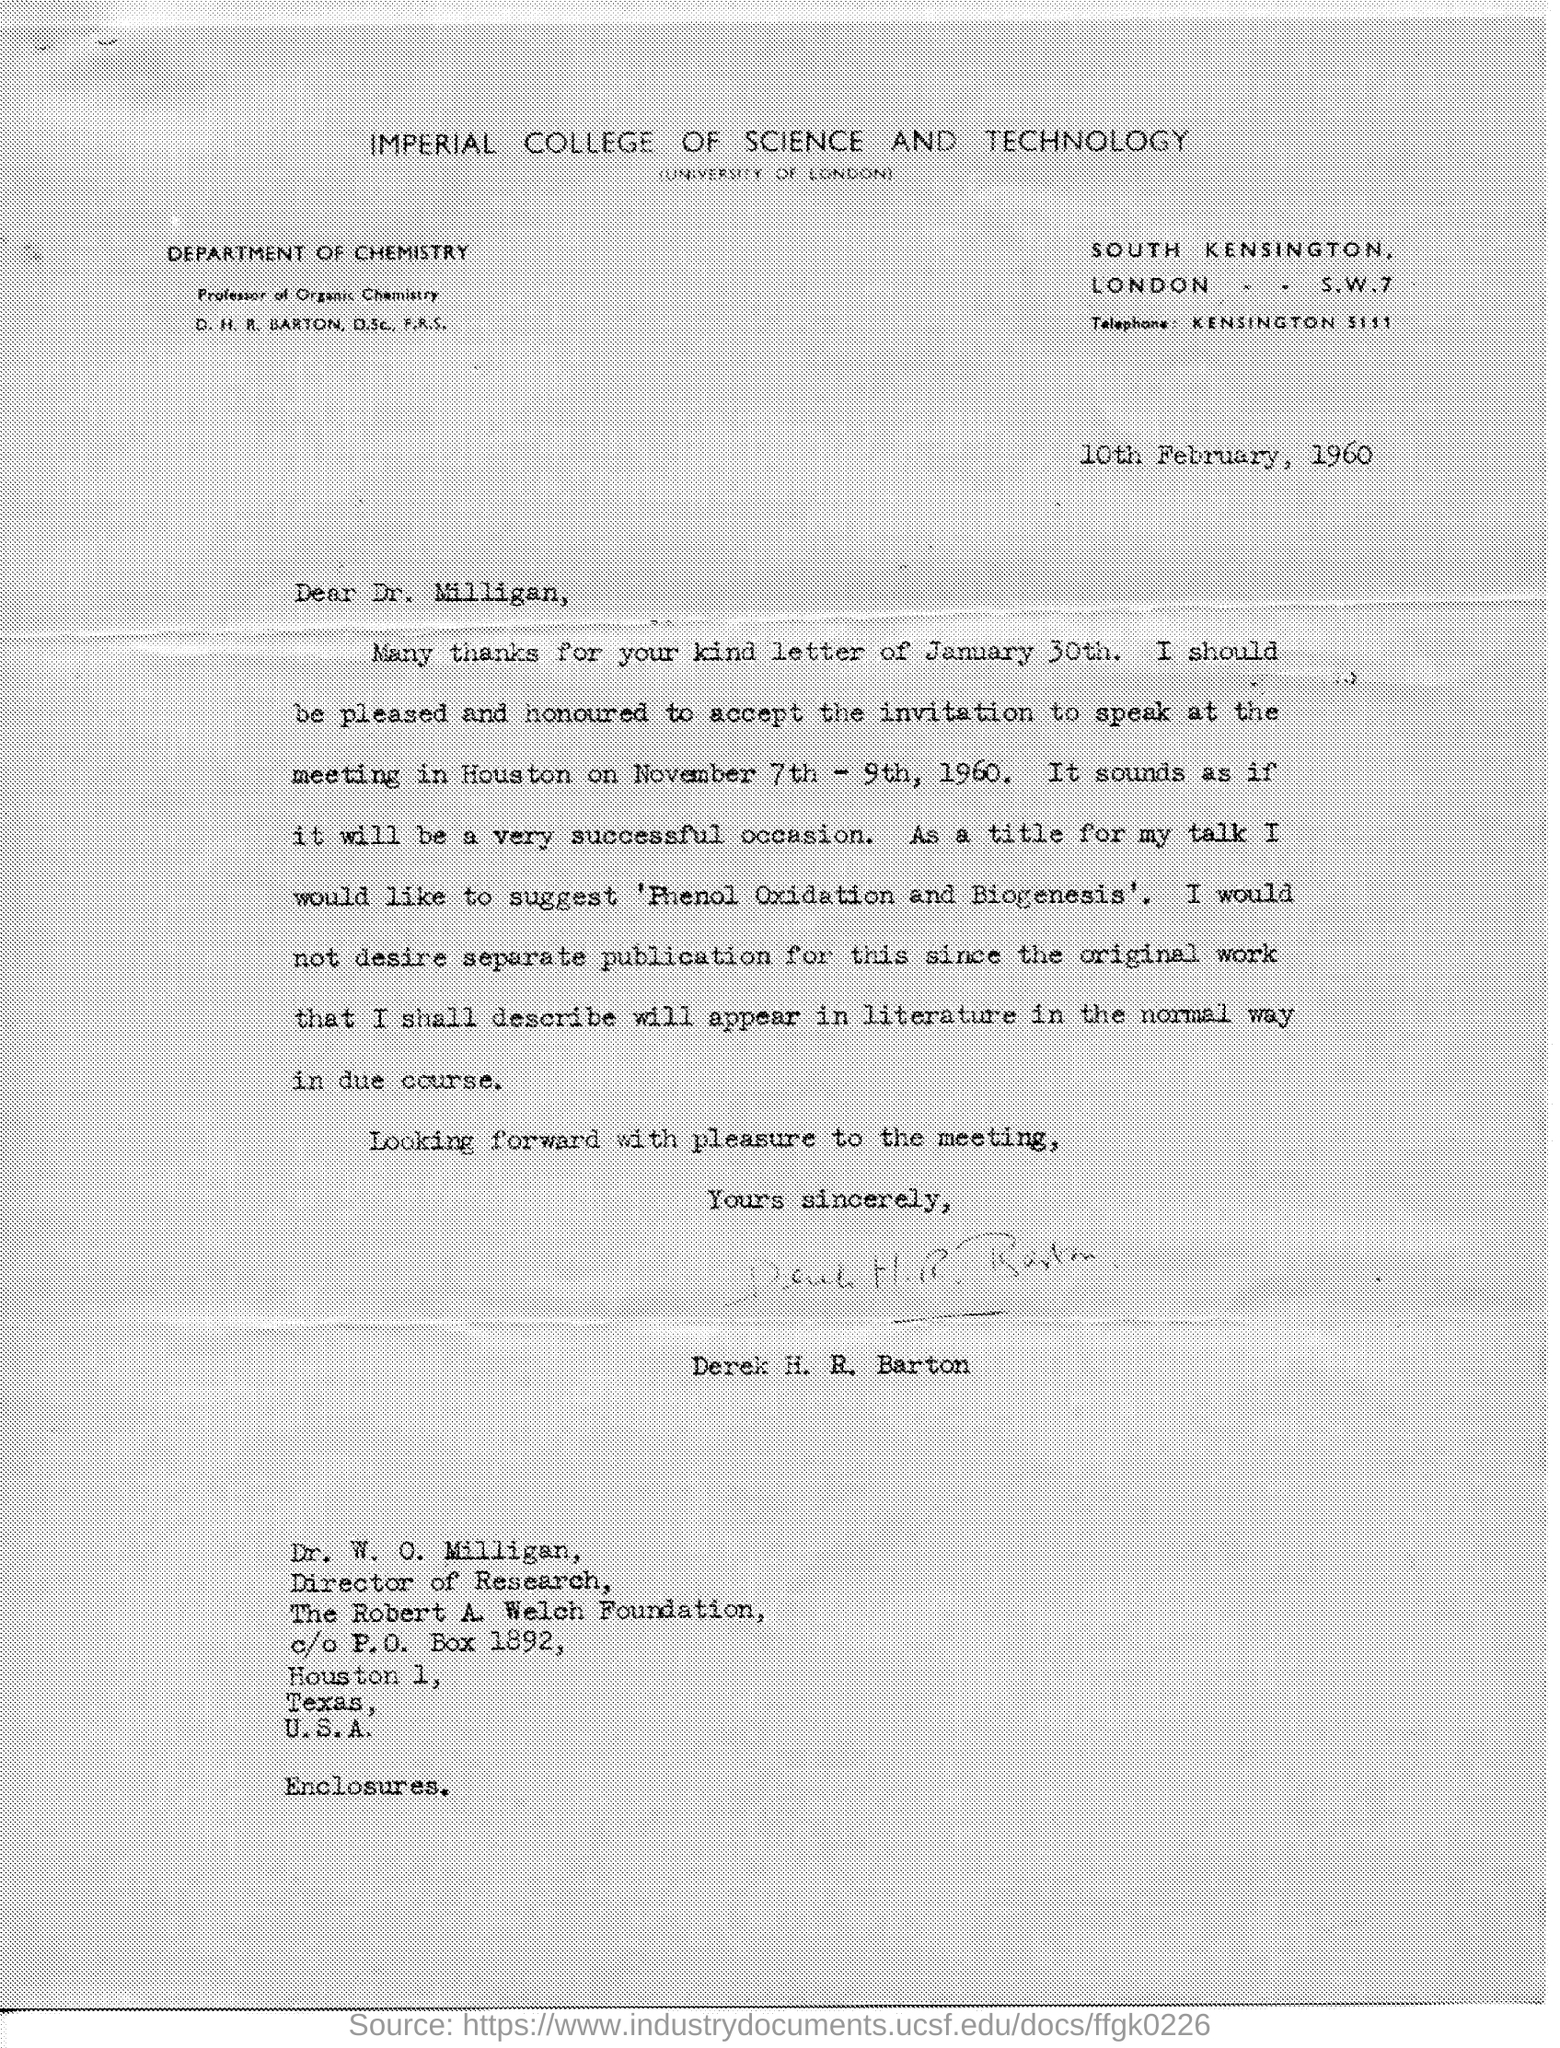What is the name of the college mentioned in the given letter?
Offer a very short reply. Imperial college of science and technology. What is the name of the department mentioned in the given letter?
Keep it short and to the point. DEPARTMENT OF CHEMISTRY. To whom this letter was written ?
Offer a terse response. Dr. Milligan. To which university the imperial college of science and technology is affiliated ??
Ensure brevity in your answer.  University of london. What is the designation of dr. w . o. milligan ?
Your response must be concise. Director. 